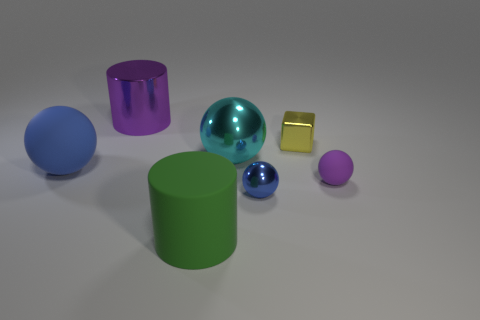Subtract 1 balls. How many balls are left? 3 Add 2 large blue spheres. How many objects exist? 9 Subtract all blocks. How many objects are left? 6 Subtract 0 red cubes. How many objects are left? 7 Subtract all tiny shiny objects. Subtract all big gray metal spheres. How many objects are left? 5 Add 7 tiny cubes. How many tiny cubes are left? 8 Add 7 gray matte things. How many gray matte things exist? 7 